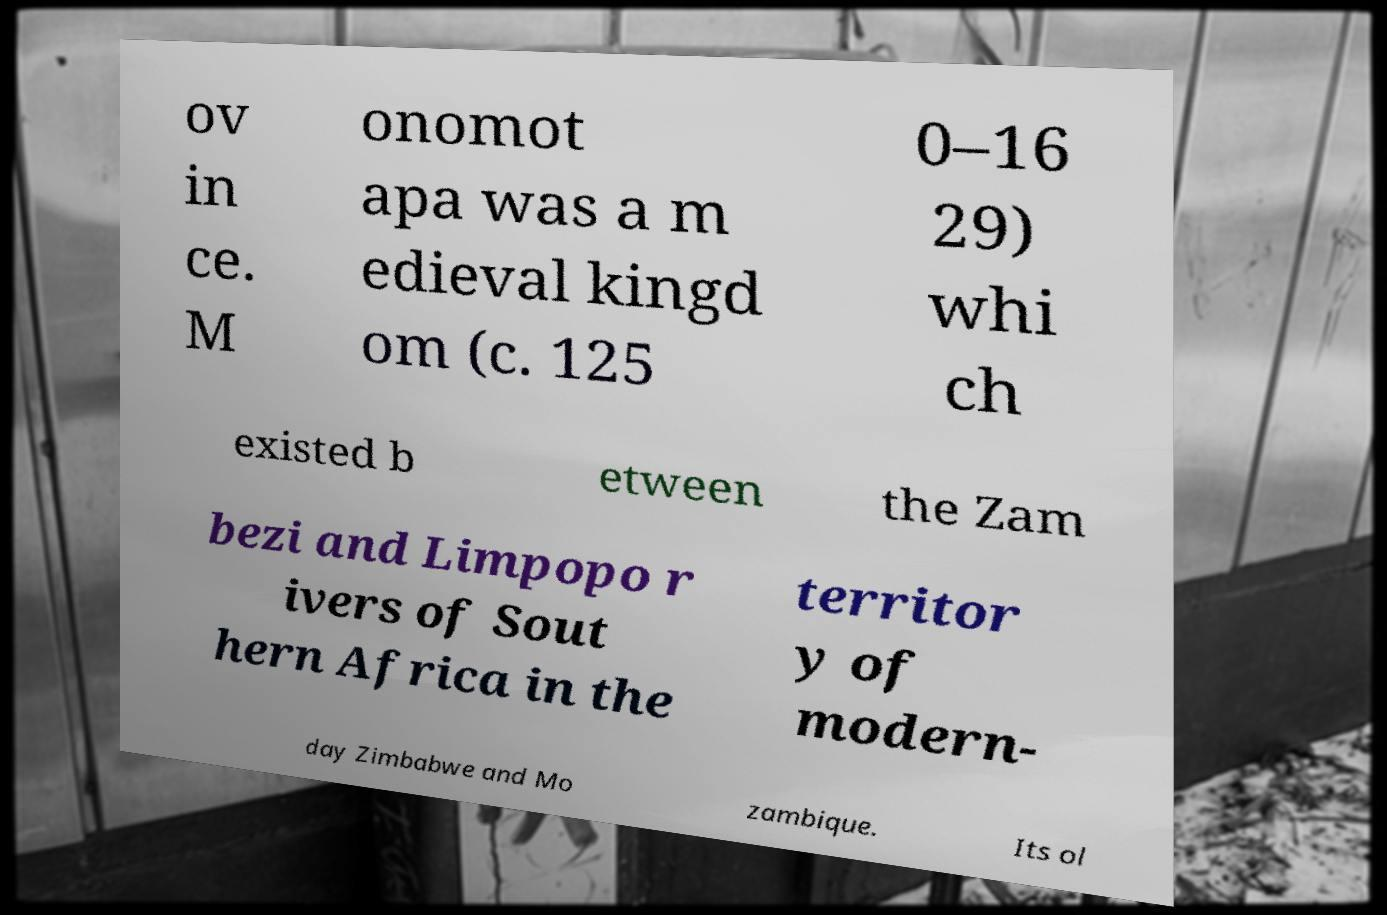What messages or text are displayed in this image? I need them in a readable, typed format. ov in ce. M onomot apa was a m edieval kingd om (c. 125 0–16 29) whi ch existed b etween the Zam bezi and Limpopo r ivers of Sout hern Africa in the territor y of modern- day Zimbabwe and Mo zambique. Its ol 